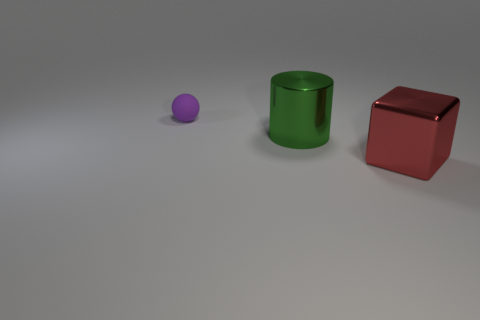What materials do the objects look like they are made of? The objects in the image seem to have a matte finish, suggesting they might be made of a type of plastic or, alternatively, a rubber-like material. The light reflections are soft and diffused, indicating they are not metallic or highly reflective. 